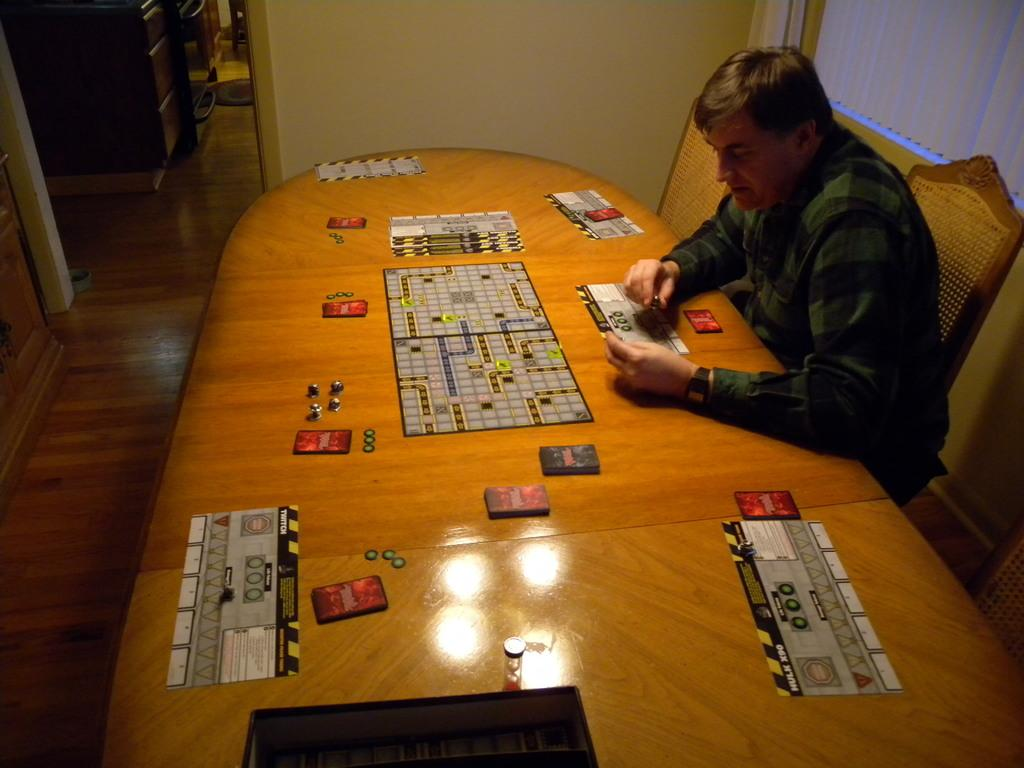Who is present in the image? There is a man in the image. What is the man doing in the image? The man is sitting in front of a table and a chair, and he is holding cards in his hands. What is happening in the image? There is a game in progress. What can be seen in the background of the image? There is a wall visible in the background of the image. What type of zebra can be seen in the image? There is no zebra present in the image. What subject is being taught in the image? There is no school or teaching activity depicted in the image. 